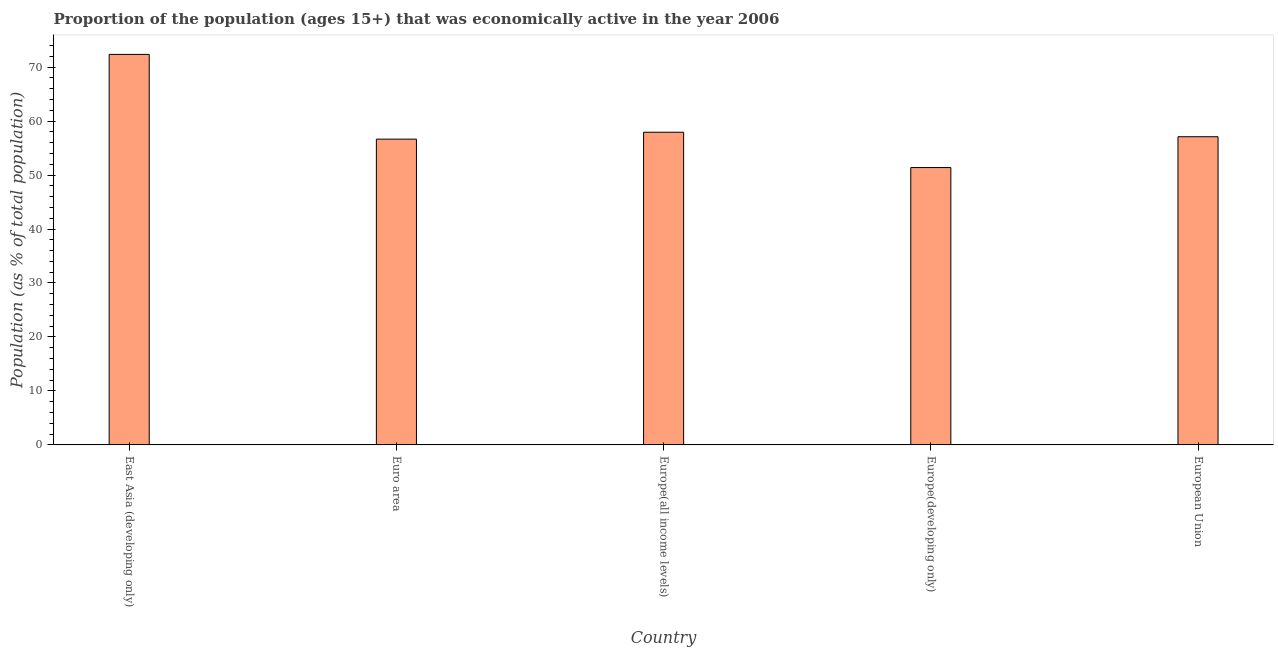Does the graph contain grids?
Offer a terse response. No. What is the title of the graph?
Ensure brevity in your answer.  Proportion of the population (ages 15+) that was economically active in the year 2006. What is the label or title of the Y-axis?
Ensure brevity in your answer.  Population (as % of total population). What is the percentage of economically active population in European Union?
Provide a succinct answer. 57.11. Across all countries, what is the maximum percentage of economically active population?
Provide a succinct answer. 72.37. Across all countries, what is the minimum percentage of economically active population?
Keep it short and to the point. 51.39. In which country was the percentage of economically active population maximum?
Your answer should be very brief. East Asia (developing only). In which country was the percentage of economically active population minimum?
Provide a short and direct response. Europe(developing only). What is the sum of the percentage of economically active population?
Your response must be concise. 295.47. What is the difference between the percentage of economically active population in Europe(all income levels) and Europe(developing only)?
Your answer should be very brief. 6.55. What is the average percentage of economically active population per country?
Offer a terse response. 59.09. What is the median percentage of economically active population?
Ensure brevity in your answer.  57.11. In how many countries, is the percentage of economically active population greater than 64 %?
Your answer should be very brief. 1. What is the ratio of the percentage of economically active population in Europe(all income levels) to that in Europe(developing only)?
Make the answer very short. 1.13. What is the difference between the highest and the second highest percentage of economically active population?
Ensure brevity in your answer.  14.43. What is the difference between the highest and the lowest percentage of economically active population?
Your answer should be compact. 20.98. How many bars are there?
Provide a succinct answer. 5. Are all the bars in the graph horizontal?
Make the answer very short. No. Are the values on the major ticks of Y-axis written in scientific E-notation?
Offer a terse response. No. What is the Population (as % of total population) of East Asia (developing only)?
Provide a succinct answer. 72.37. What is the Population (as % of total population) in Euro area?
Your answer should be compact. 56.66. What is the Population (as % of total population) in Europe(all income levels)?
Provide a short and direct response. 57.94. What is the Population (as % of total population) of Europe(developing only)?
Provide a short and direct response. 51.39. What is the Population (as % of total population) of European Union?
Make the answer very short. 57.11. What is the difference between the Population (as % of total population) in East Asia (developing only) and Euro area?
Your answer should be compact. 15.71. What is the difference between the Population (as % of total population) in East Asia (developing only) and Europe(all income levels)?
Your answer should be very brief. 14.43. What is the difference between the Population (as % of total population) in East Asia (developing only) and Europe(developing only)?
Provide a short and direct response. 20.98. What is the difference between the Population (as % of total population) in East Asia (developing only) and European Union?
Your answer should be very brief. 15.26. What is the difference between the Population (as % of total population) in Euro area and Europe(all income levels)?
Provide a short and direct response. -1.28. What is the difference between the Population (as % of total population) in Euro area and Europe(developing only)?
Provide a short and direct response. 5.27. What is the difference between the Population (as % of total population) in Euro area and European Union?
Offer a terse response. -0.45. What is the difference between the Population (as % of total population) in Europe(all income levels) and Europe(developing only)?
Make the answer very short. 6.55. What is the difference between the Population (as % of total population) in Europe(all income levels) and European Union?
Offer a very short reply. 0.84. What is the difference between the Population (as % of total population) in Europe(developing only) and European Union?
Provide a succinct answer. -5.71. What is the ratio of the Population (as % of total population) in East Asia (developing only) to that in Euro area?
Give a very brief answer. 1.28. What is the ratio of the Population (as % of total population) in East Asia (developing only) to that in Europe(all income levels)?
Make the answer very short. 1.25. What is the ratio of the Population (as % of total population) in East Asia (developing only) to that in Europe(developing only)?
Keep it short and to the point. 1.41. What is the ratio of the Population (as % of total population) in East Asia (developing only) to that in European Union?
Provide a succinct answer. 1.27. What is the ratio of the Population (as % of total population) in Euro area to that in Europe(all income levels)?
Keep it short and to the point. 0.98. What is the ratio of the Population (as % of total population) in Euro area to that in Europe(developing only)?
Give a very brief answer. 1.1. What is the ratio of the Population (as % of total population) in Europe(all income levels) to that in Europe(developing only)?
Your answer should be compact. 1.13. What is the ratio of the Population (as % of total population) in Europe(all income levels) to that in European Union?
Keep it short and to the point. 1.01. What is the ratio of the Population (as % of total population) in Europe(developing only) to that in European Union?
Ensure brevity in your answer.  0.9. 